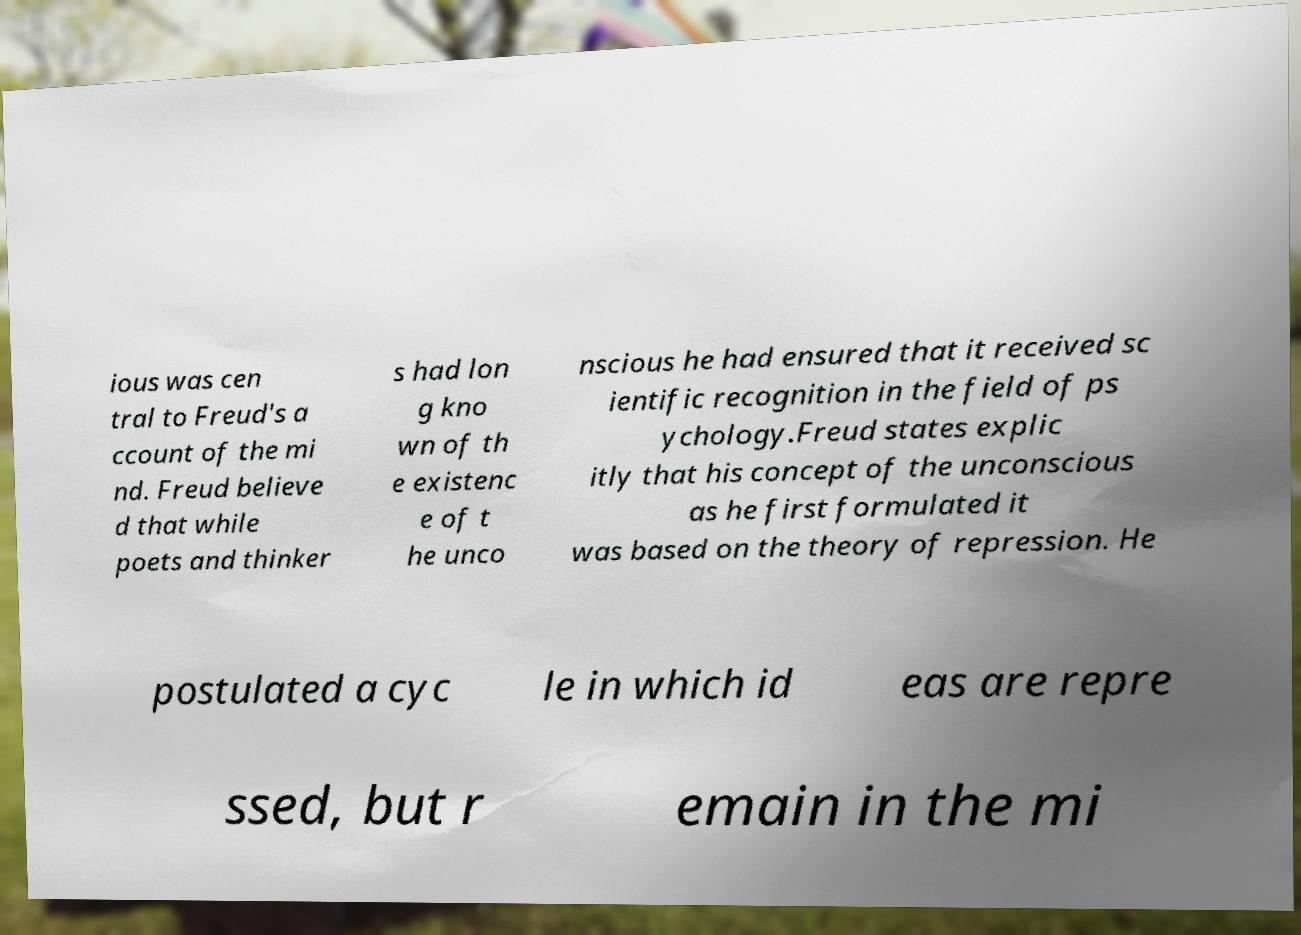Can you accurately transcribe the text from the provided image for me? ious was cen tral to Freud's a ccount of the mi nd. Freud believe d that while poets and thinker s had lon g kno wn of th e existenc e of t he unco nscious he had ensured that it received sc ientific recognition in the field of ps ychology.Freud states explic itly that his concept of the unconscious as he first formulated it was based on the theory of repression. He postulated a cyc le in which id eas are repre ssed, but r emain in the mi 